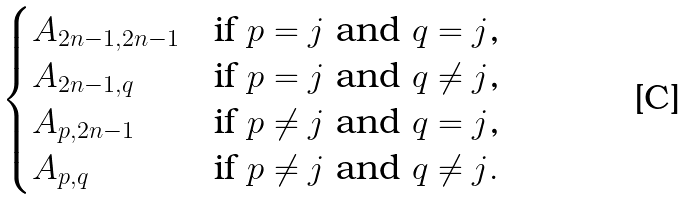Convert formula to latex. <formula><loc_0><loc_0><loc_500><loc_500>\begin{cases} A _ { 2 n - 1 , 2 n - 1 } & \text {if $p=j$ and $q=j$,} \\ A _ { 2 n - 1 , q } & \text {if $p=j$ and $q \not=j$,} \\ A _ { p , 2 n - 1 } & \text {if $p \not=j$ and $q=j$,} \\ A _ { p , q } & \text {if $p \not=j$ and $q \not=j$} . \end{cases}</formula> 